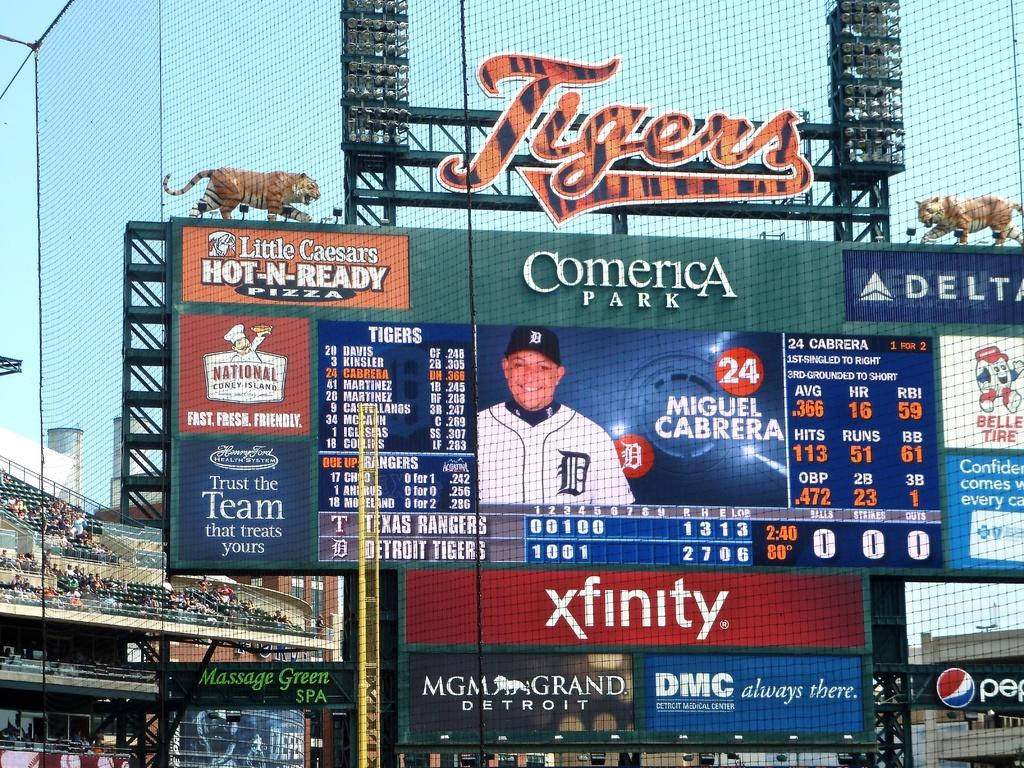Provide a one-sentence caption for the provided image. a sign that says comerica at the top of it. 